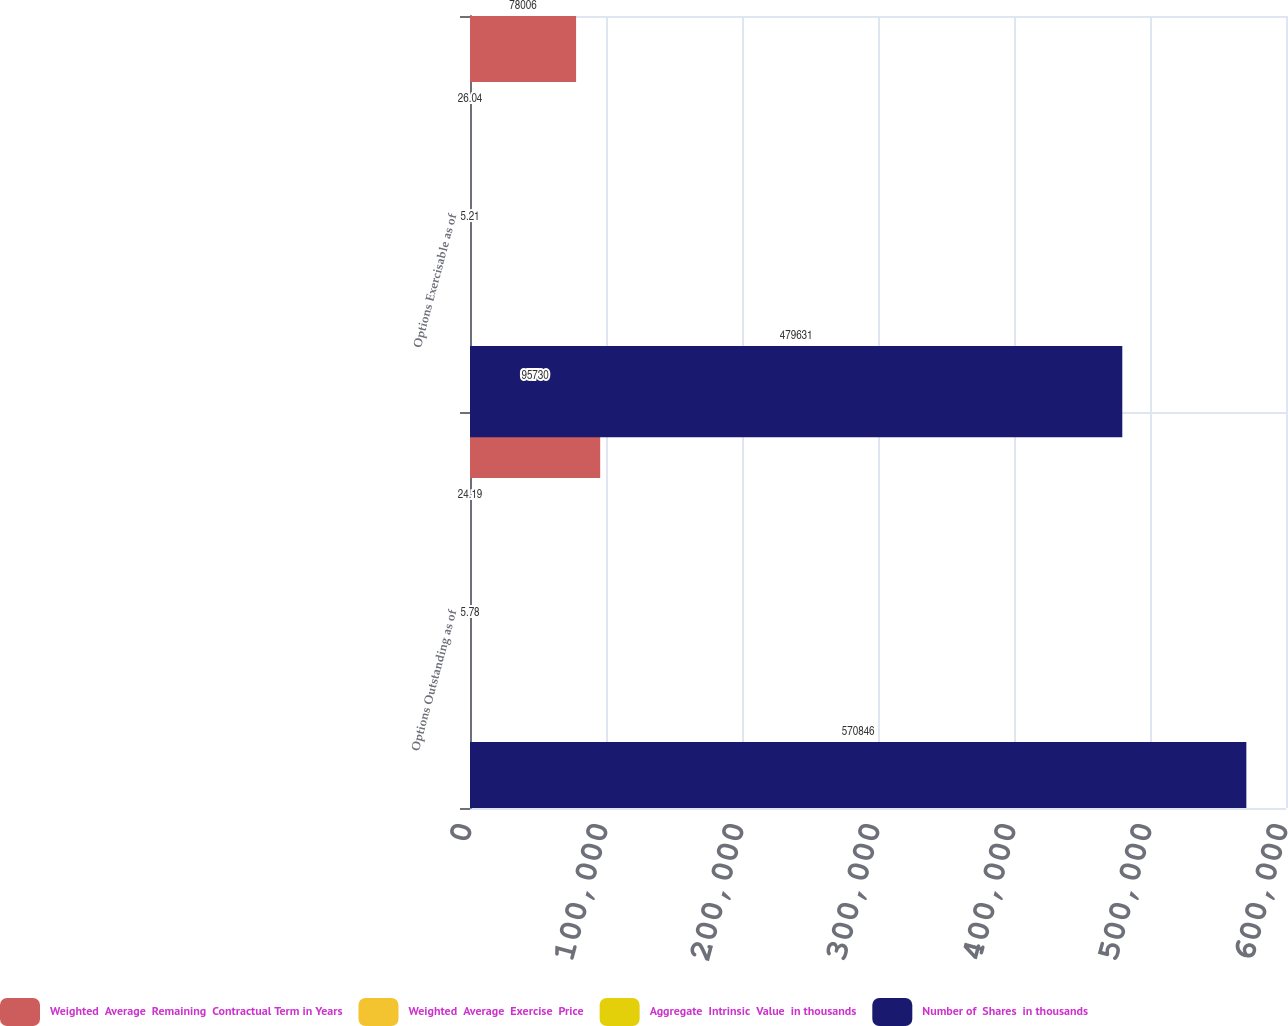<chart> <loc_0><loc_0><loc_500><loc_500><stacked_bar_chart><ecel><fcel>Options Outstanding as of<fcel>Options Exercisable as of<nl><fcel>Weighted  Average  Remaining  Contractual Term in Years<fcel>95730<fcel>78006<nl><fcel>Weighted  Average  Exercise  Price<fcel>24.19<fcel>26.04<nl><fcel>Aggregate  Intrinsic  Value  in thousands<fcel>5.78<fcel>5.21<nl><fcel>Number of  Shares  in thousands<fcel>570846<fcel>479631<nl></chart> 